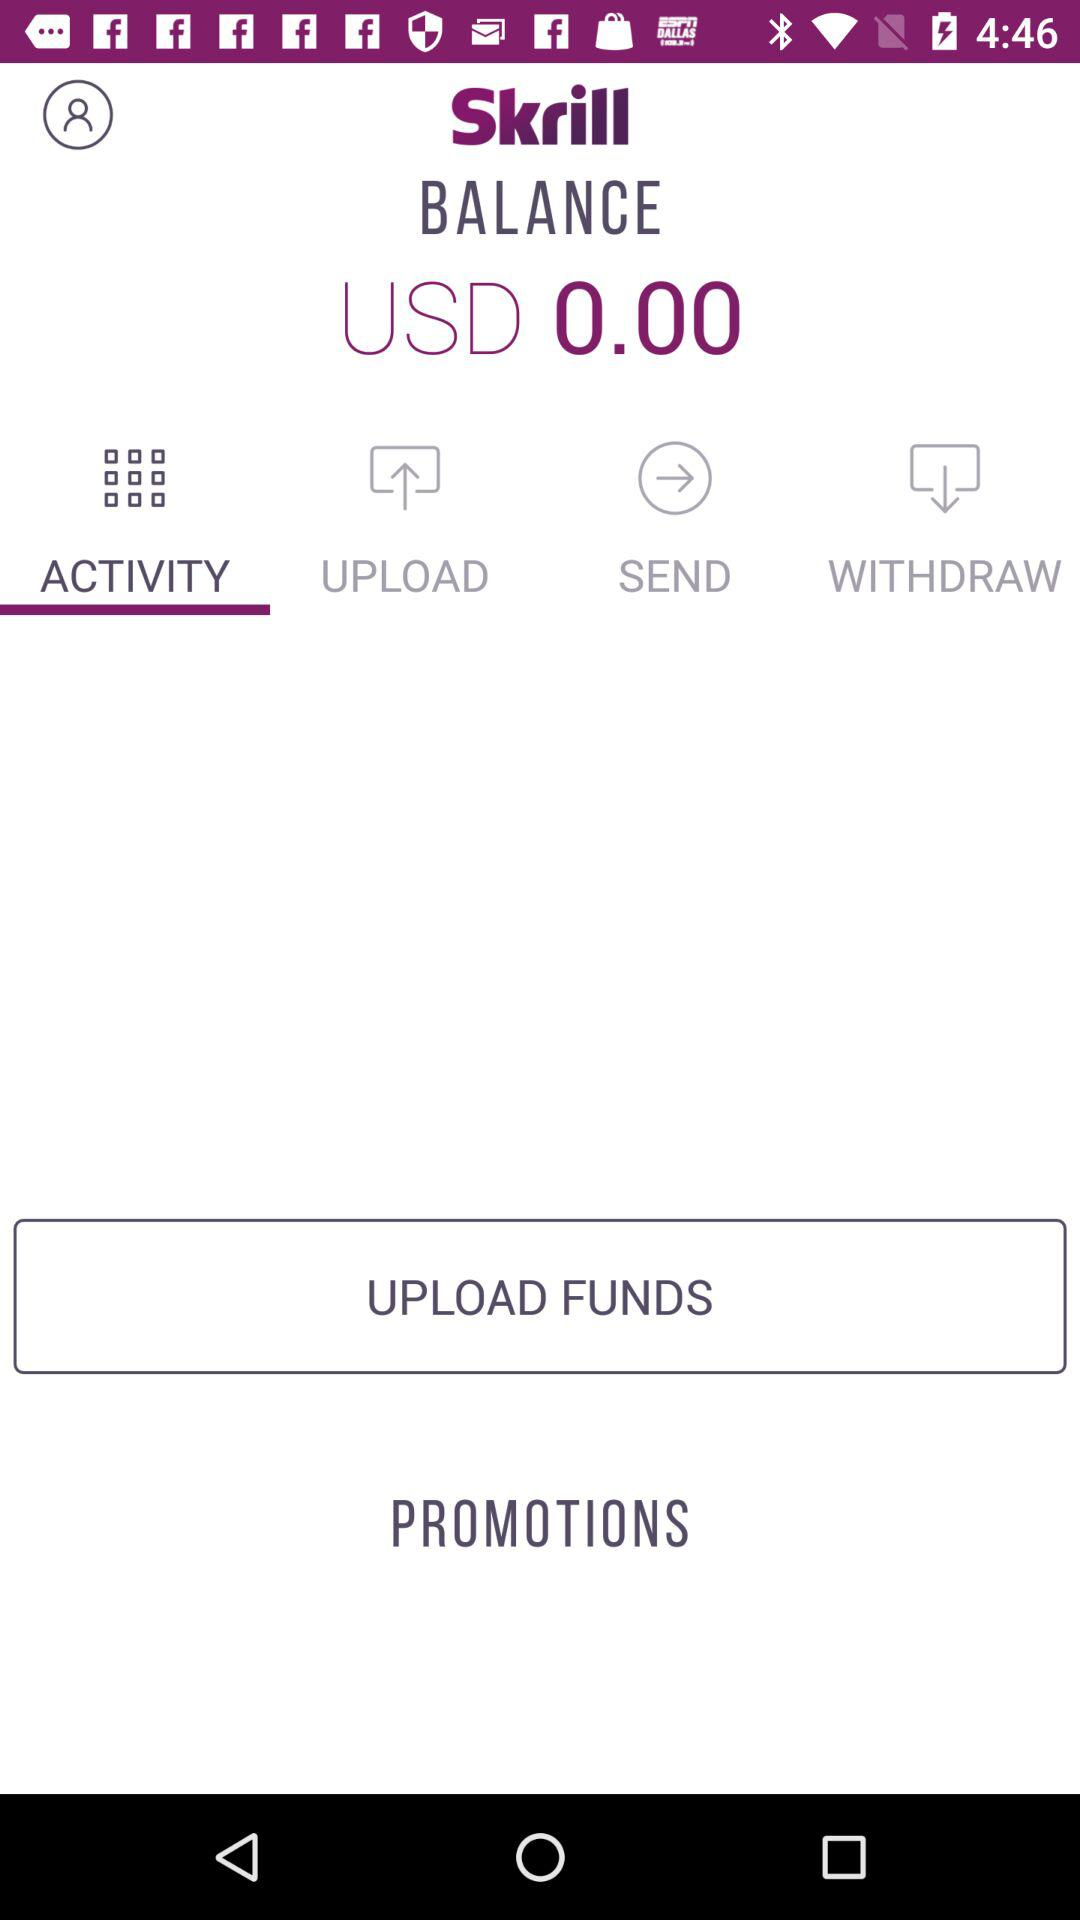Which tab is selected? The selected tab is "ACTIVITY". 